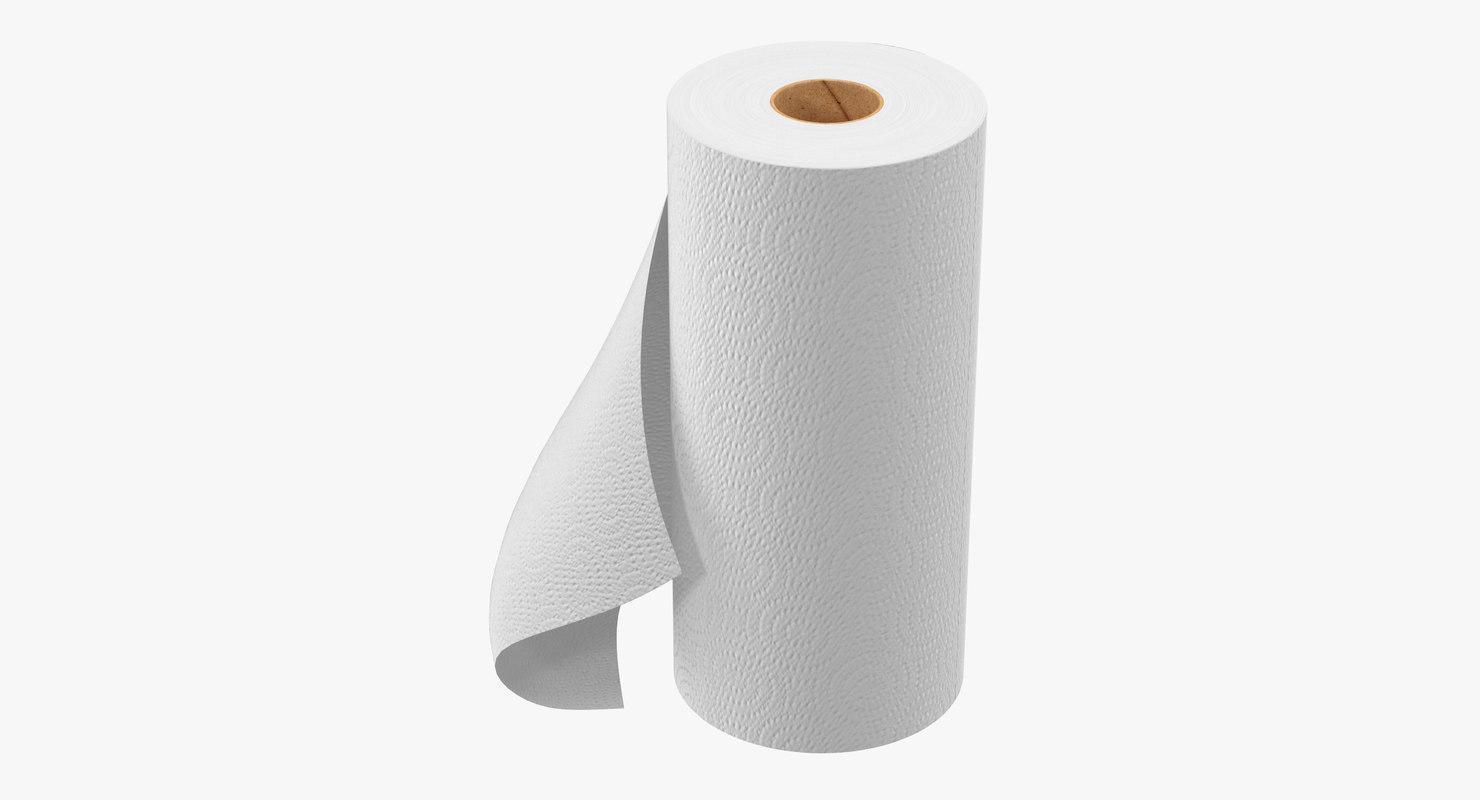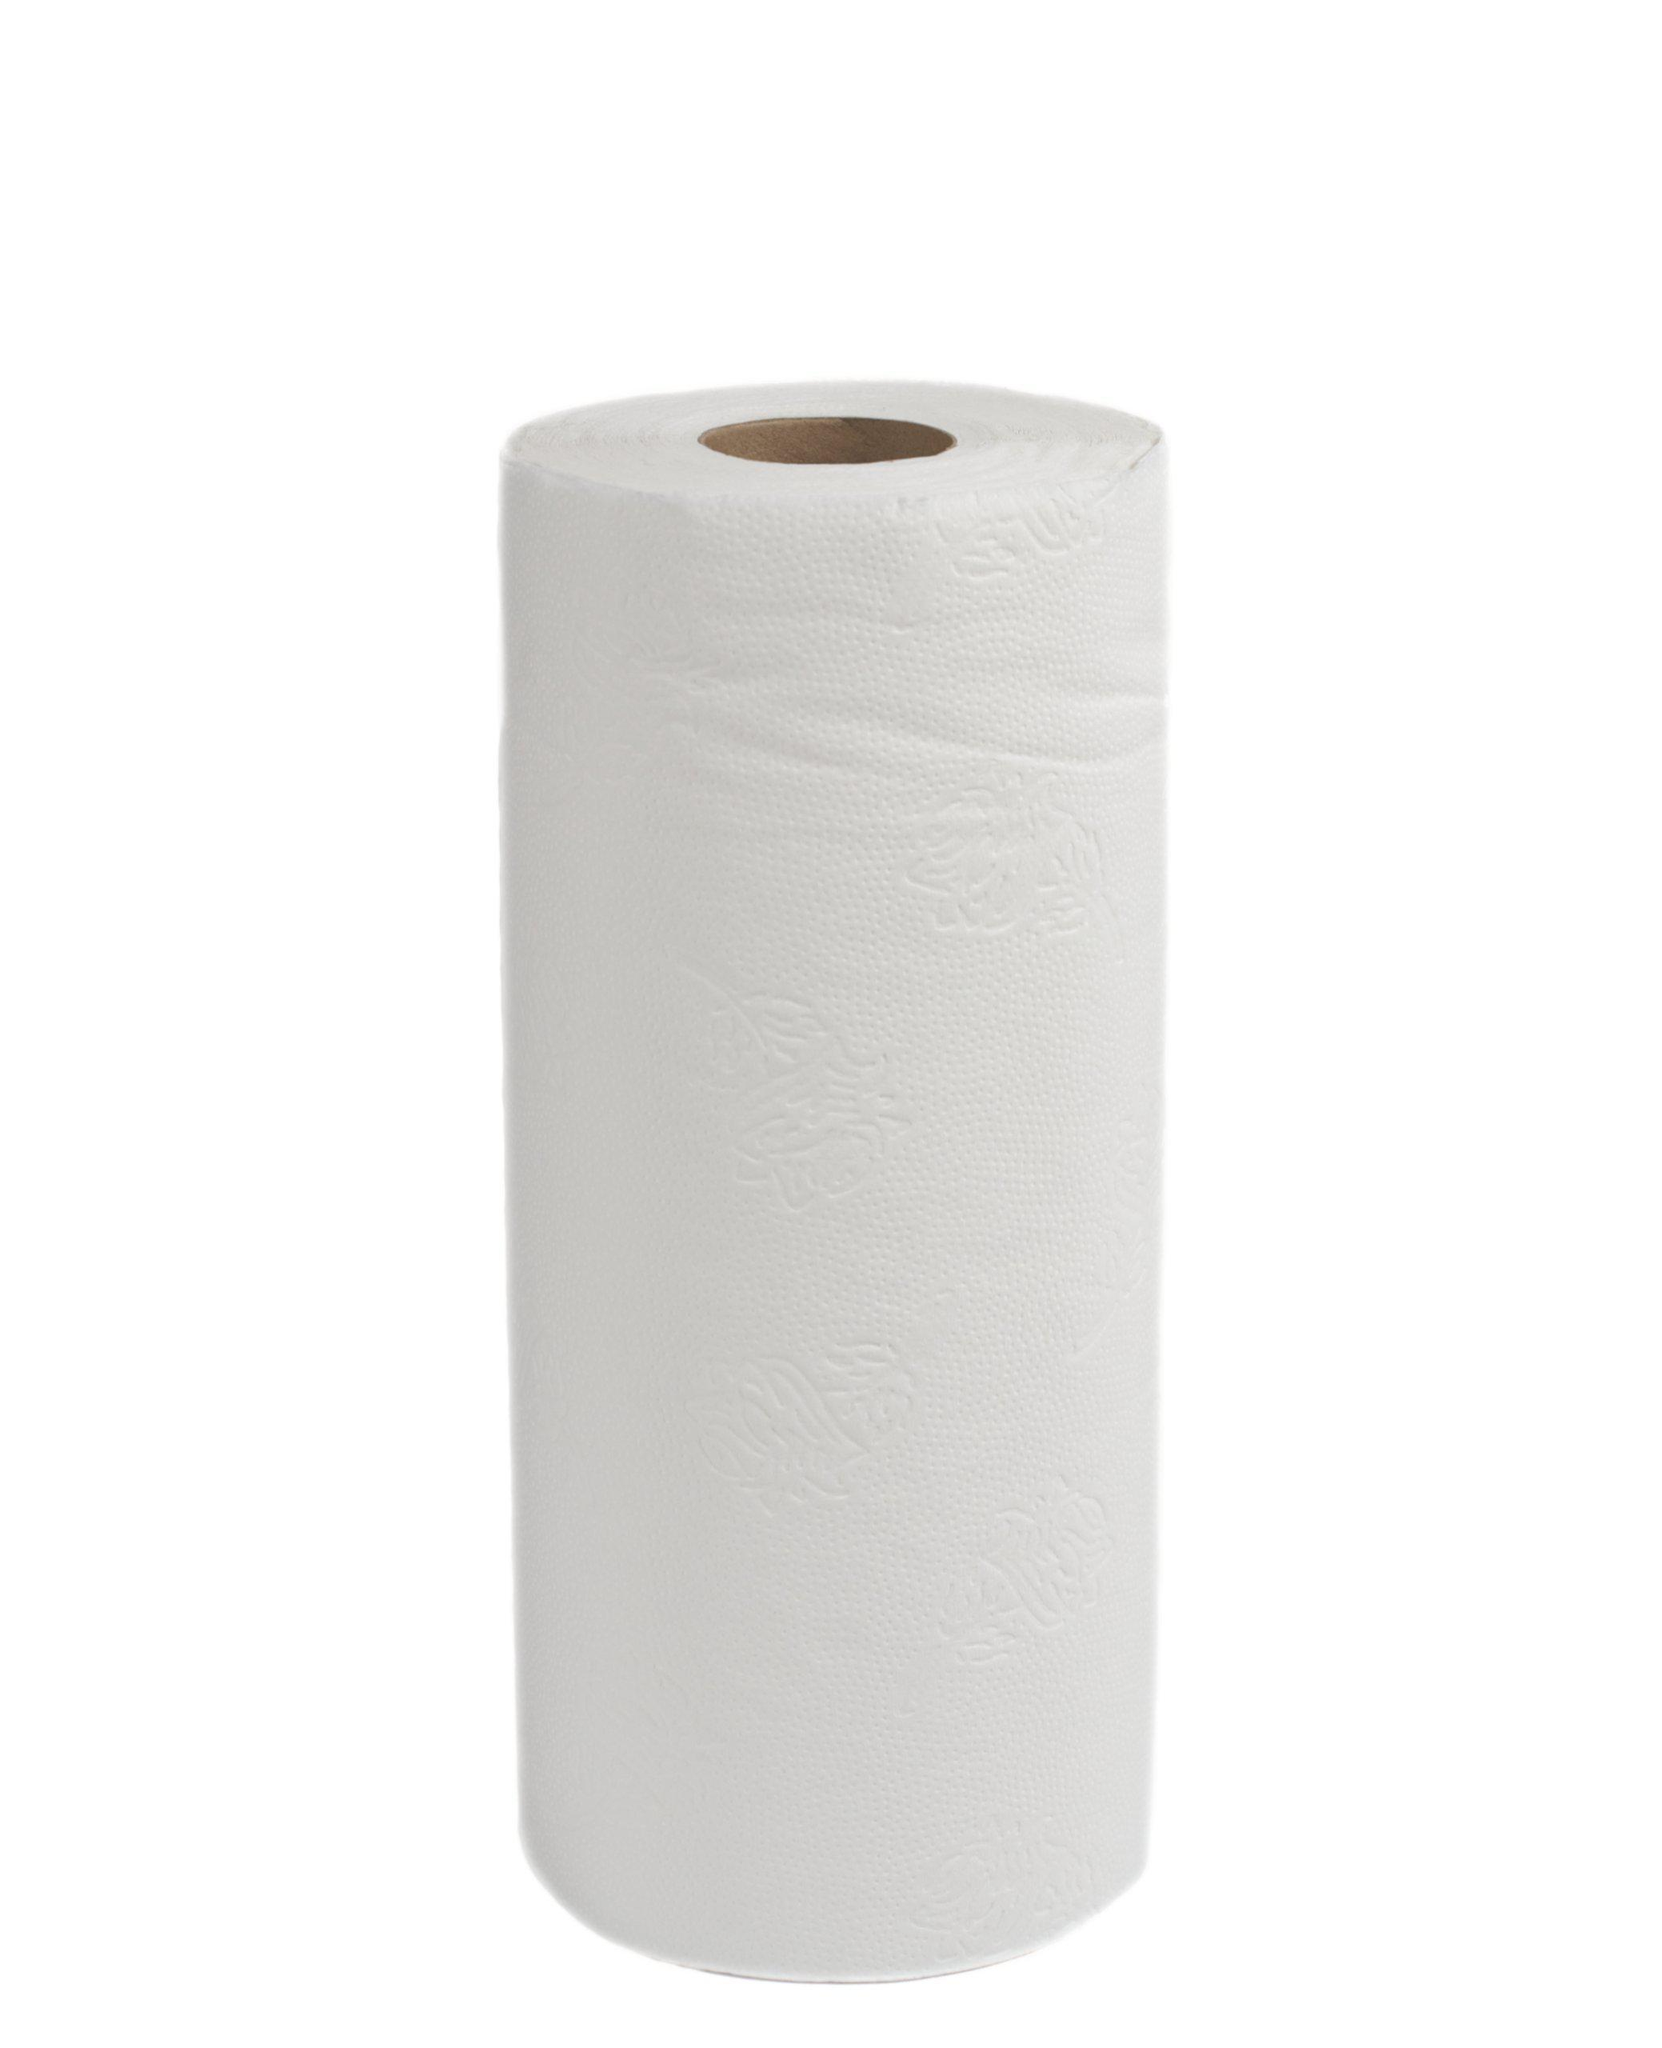The first image is the image on the left, the second image is the image on the right. Examine the images to the left and right. Is the description "One roll of tan and one roll of white paper towels are laying horizontally." accurate? Answer yes or no. No. 